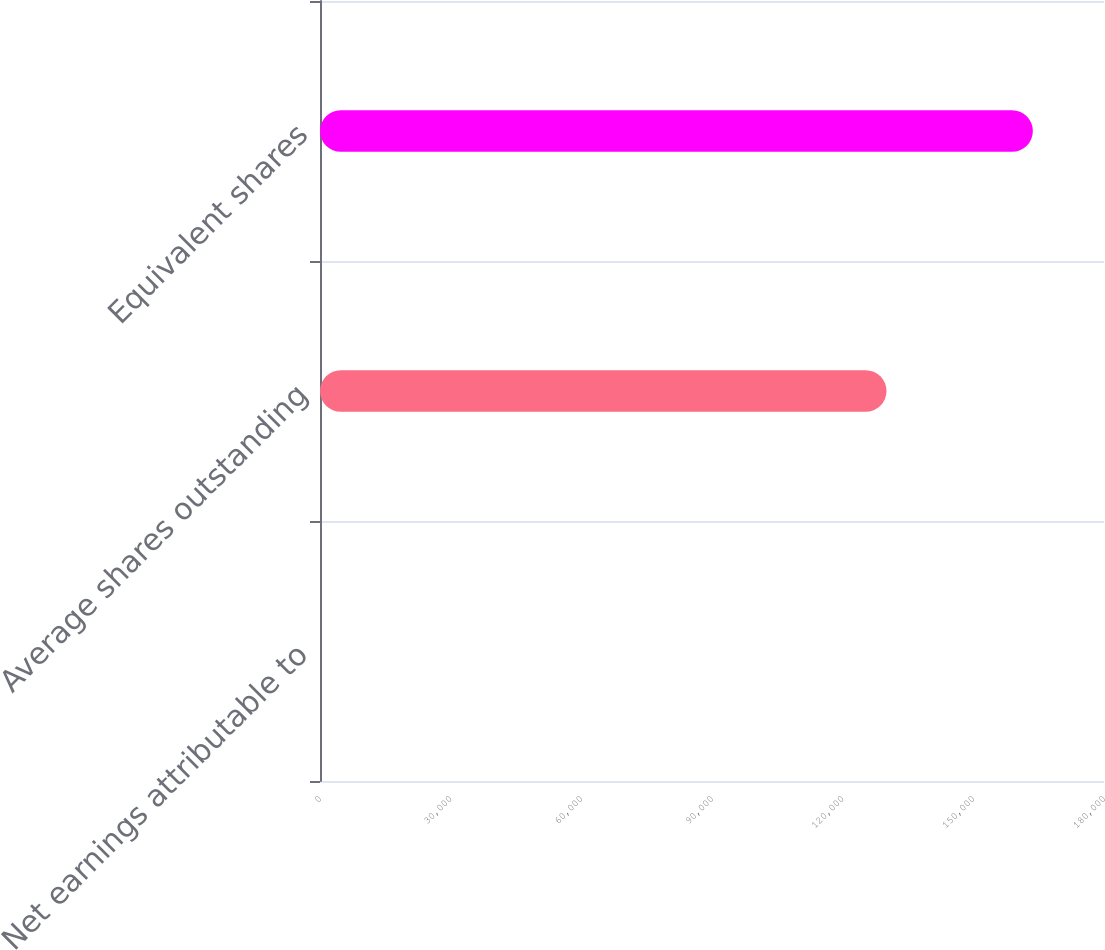Convert chart to OTSL. <chart><loc_0><loc_0><loc_500><loc_500><bar_chart><fcel>Net earnings attributable to<fcel>Average shares outstanding<fcel>Equivalent shares<nl><fcel>2.55<fcel>130067<fcel>163667<nl></chart> 